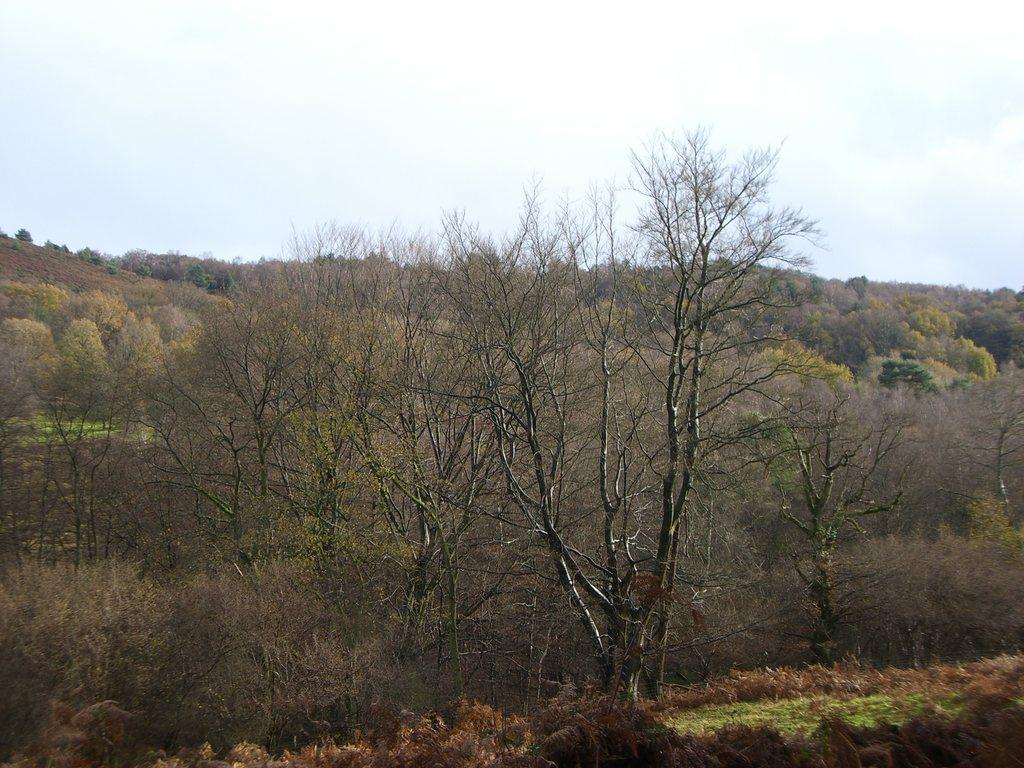What type of vegetation can be seen in the image? There are trees and plants in the image. What is visible at the top of the image? The sky is visible at the top of the image. What type of religious symbol can be seen in the image? There is no religious symbol present in the image; it features trees, plants, and the sky. What type of bird is singing in rhythm in the image? There is no bird present in the image, and therefore no singing or rhythm can be observed. 